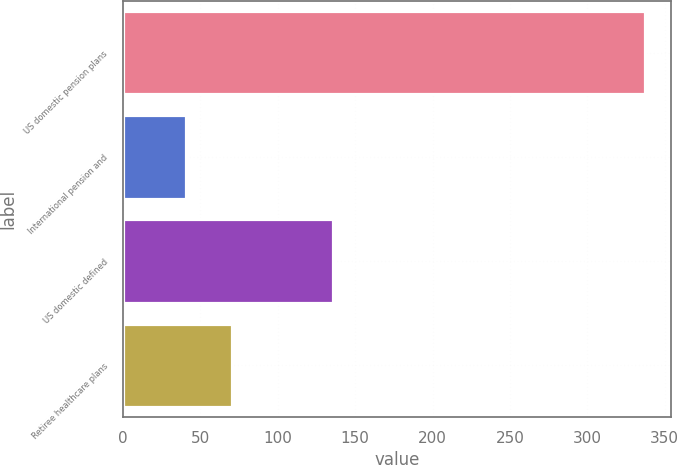<chart> <loc_0><loc_0><loc_500><loc_500><bar_chart><fcel>US domestic pension plans<fcel>International pension and<fcel>US domestic defined<fcel>Retiree healthcare plans<nl><fcel>337<fcel>41<fcel>136<fcel>70.6<nl></chart> 